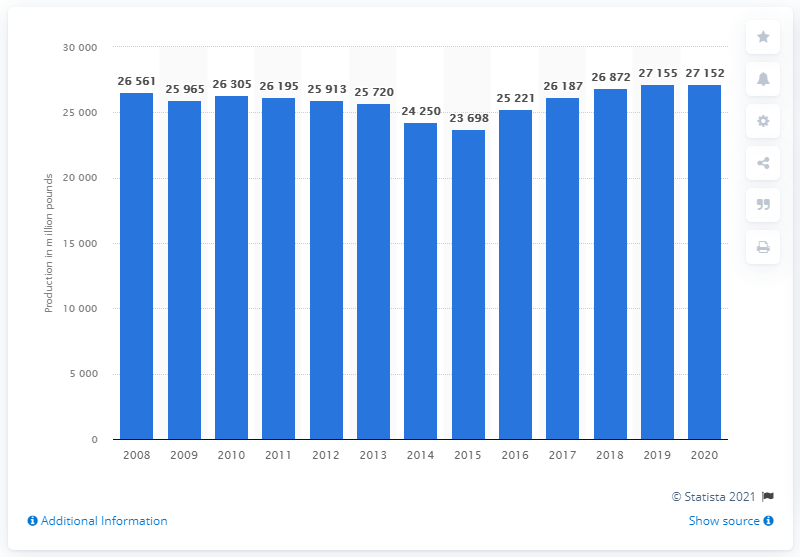Mention a couple of crucial points in this snapshot. In 2020, the commercial beef production of the United States was 27,152 head. 